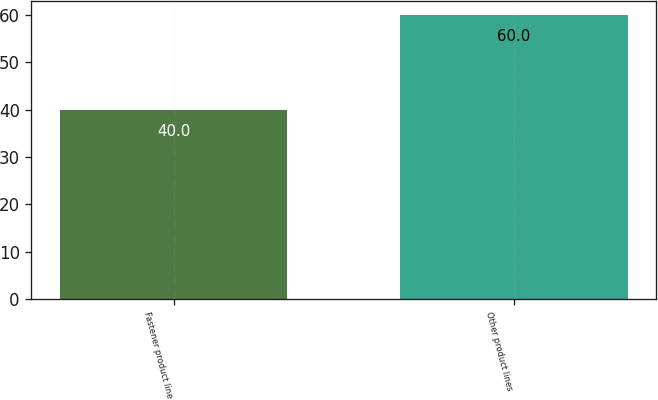<chart> <loc_0><loc_0><loc_500><loc_500><bar_chart><fcel>Fastener product line<fcel>Other product lines<nl><fcel>40<fcel>60<nl></chart> 